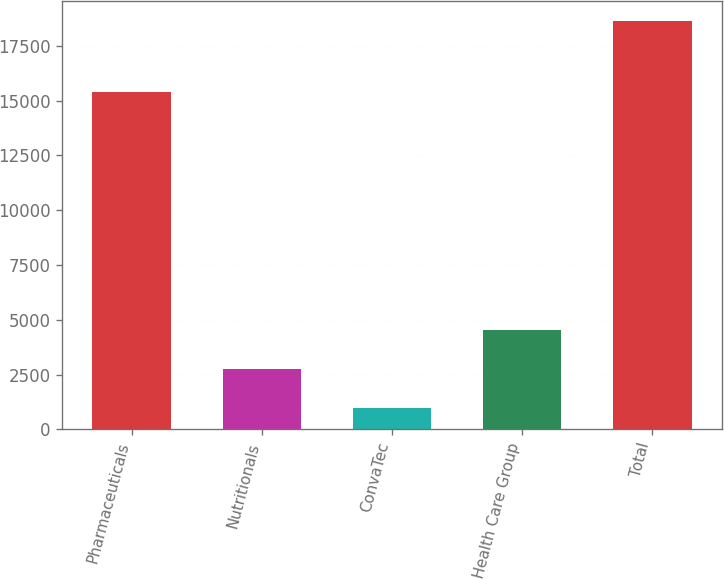Convert chart. <chart><loc_0><loc_0><loc_500><loc_500><bar_chart><fcel>Pharmaceuticals<fcel>Nutritionals<fcel>ConvaTec<fcel>Health Care Group<fcel>Total<nl><fcel>15408<fcel>2753.3<fcel>992<fcel>4514.6<fcel>18605<nl></chart> 